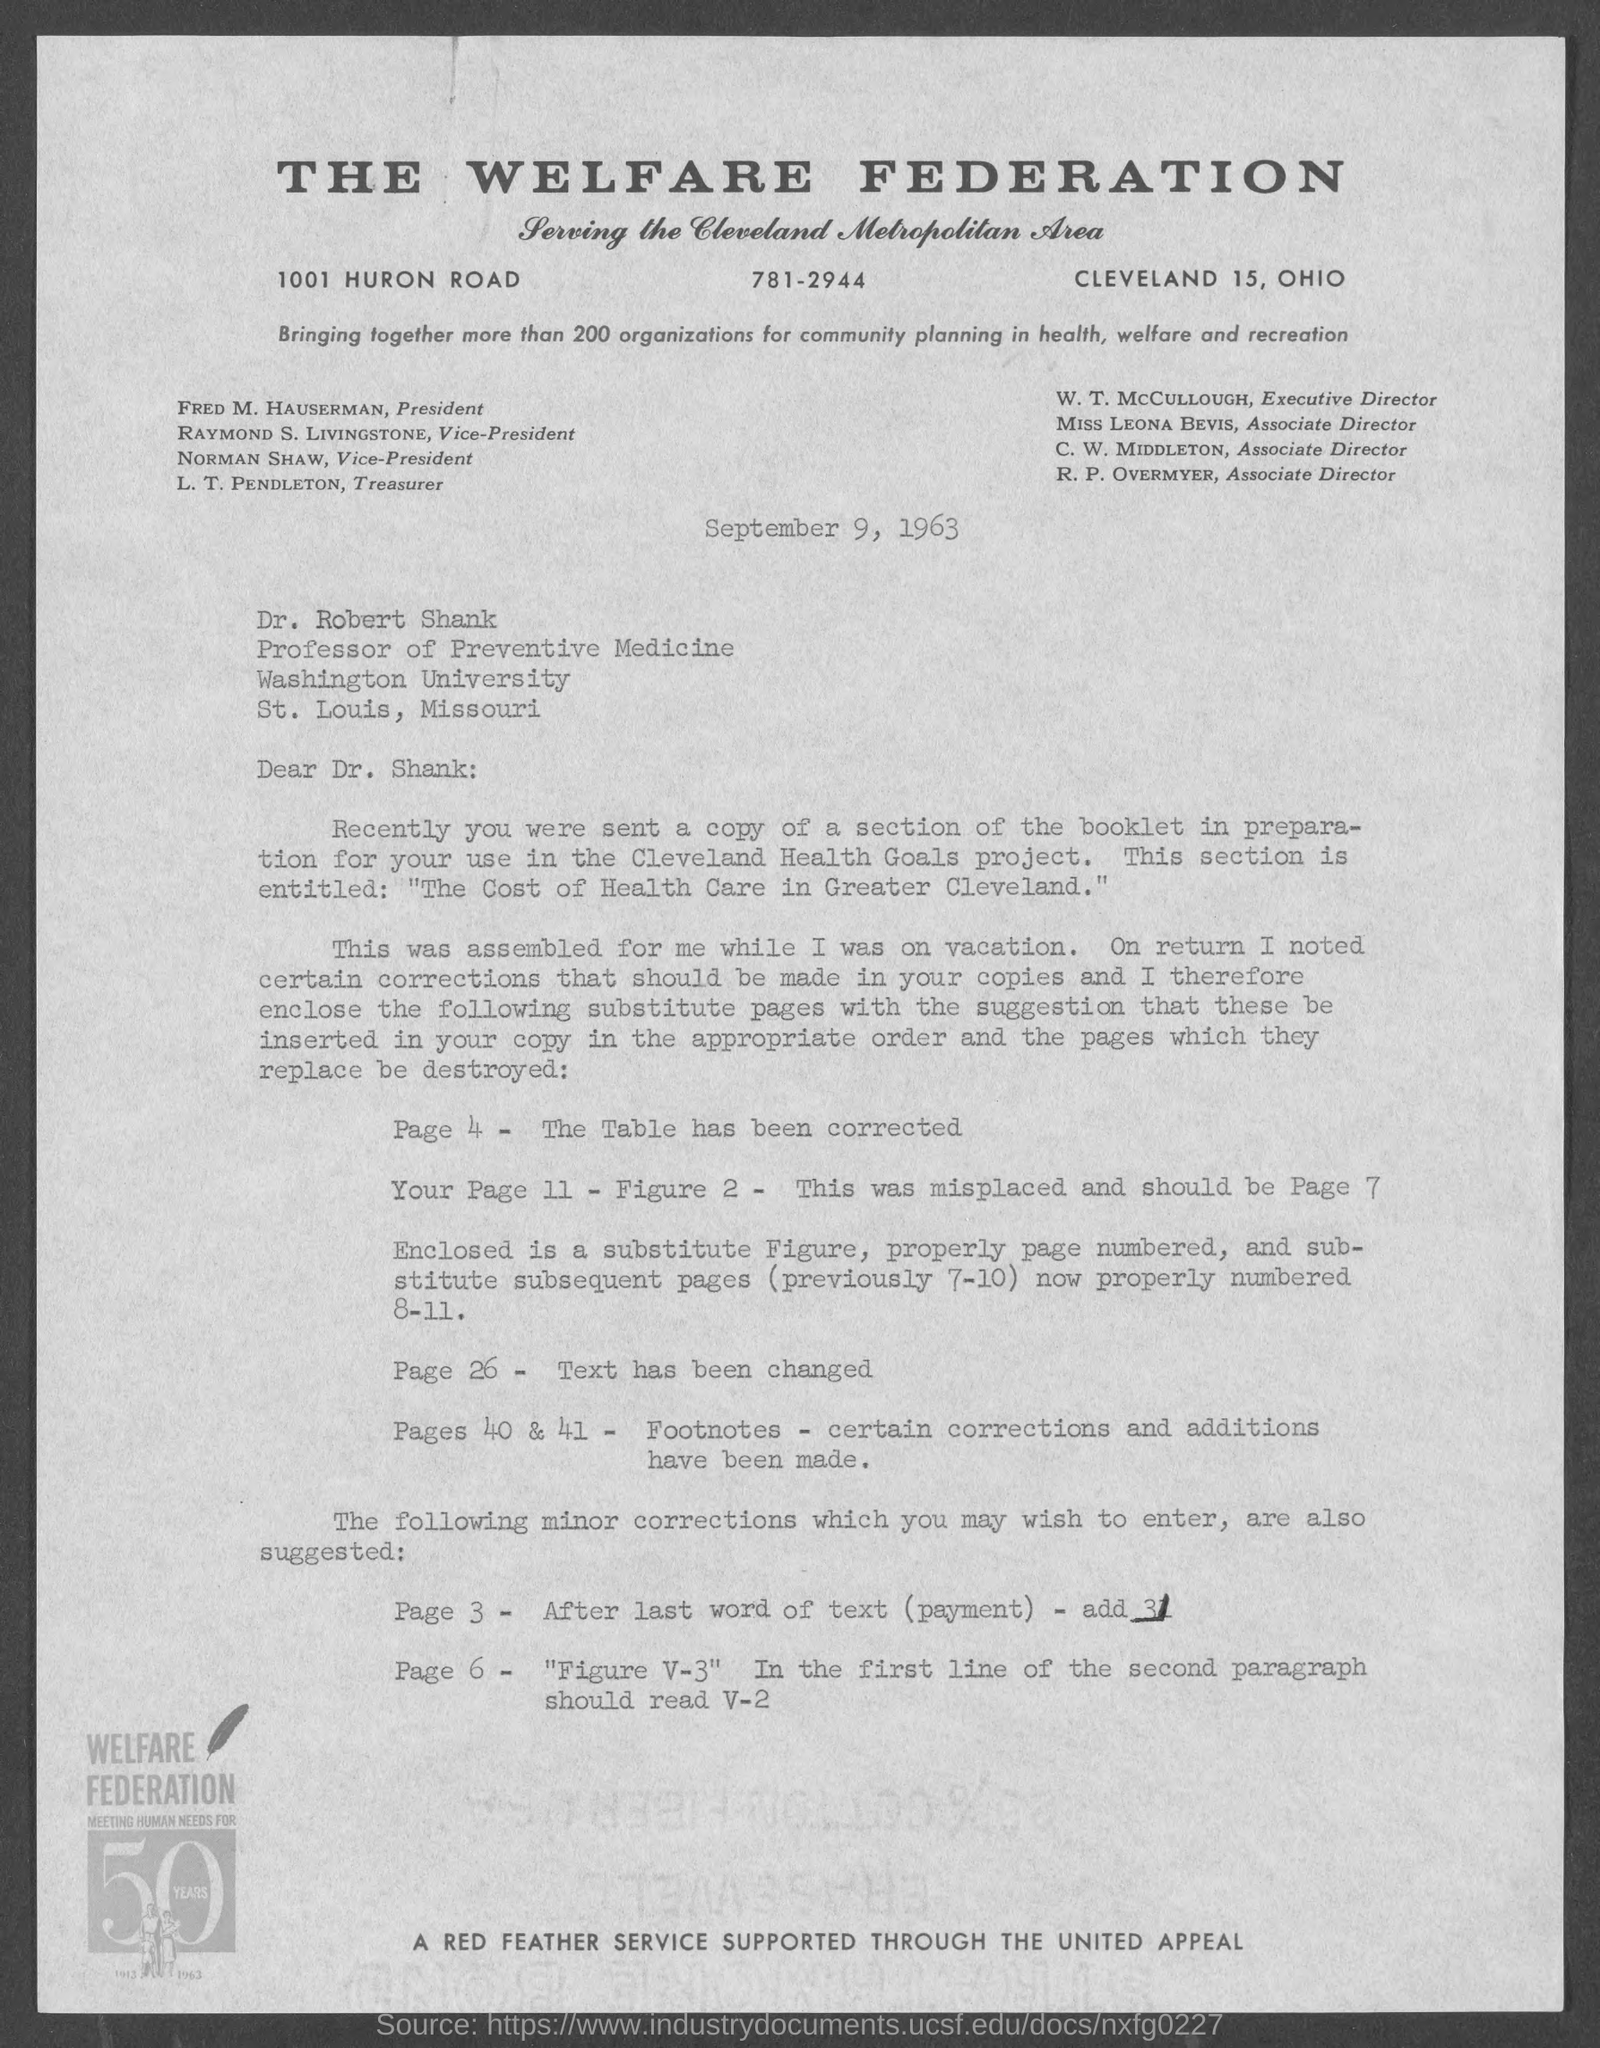Indicate a few pertinent items in this graphic. Dr. Robert Shank holds the position of Professor of Preventive Medicine. Fred M. Hauserman is the President of The Welfare Federation. The Welfare Federation's telephone number is 781-2944. 